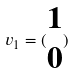<formula> <loc_0><loc_0><loc_500><loc_500>v _ { 1 } = ( \begin{matrix} 1 \\ 0 \end{matrix} )</formula> 